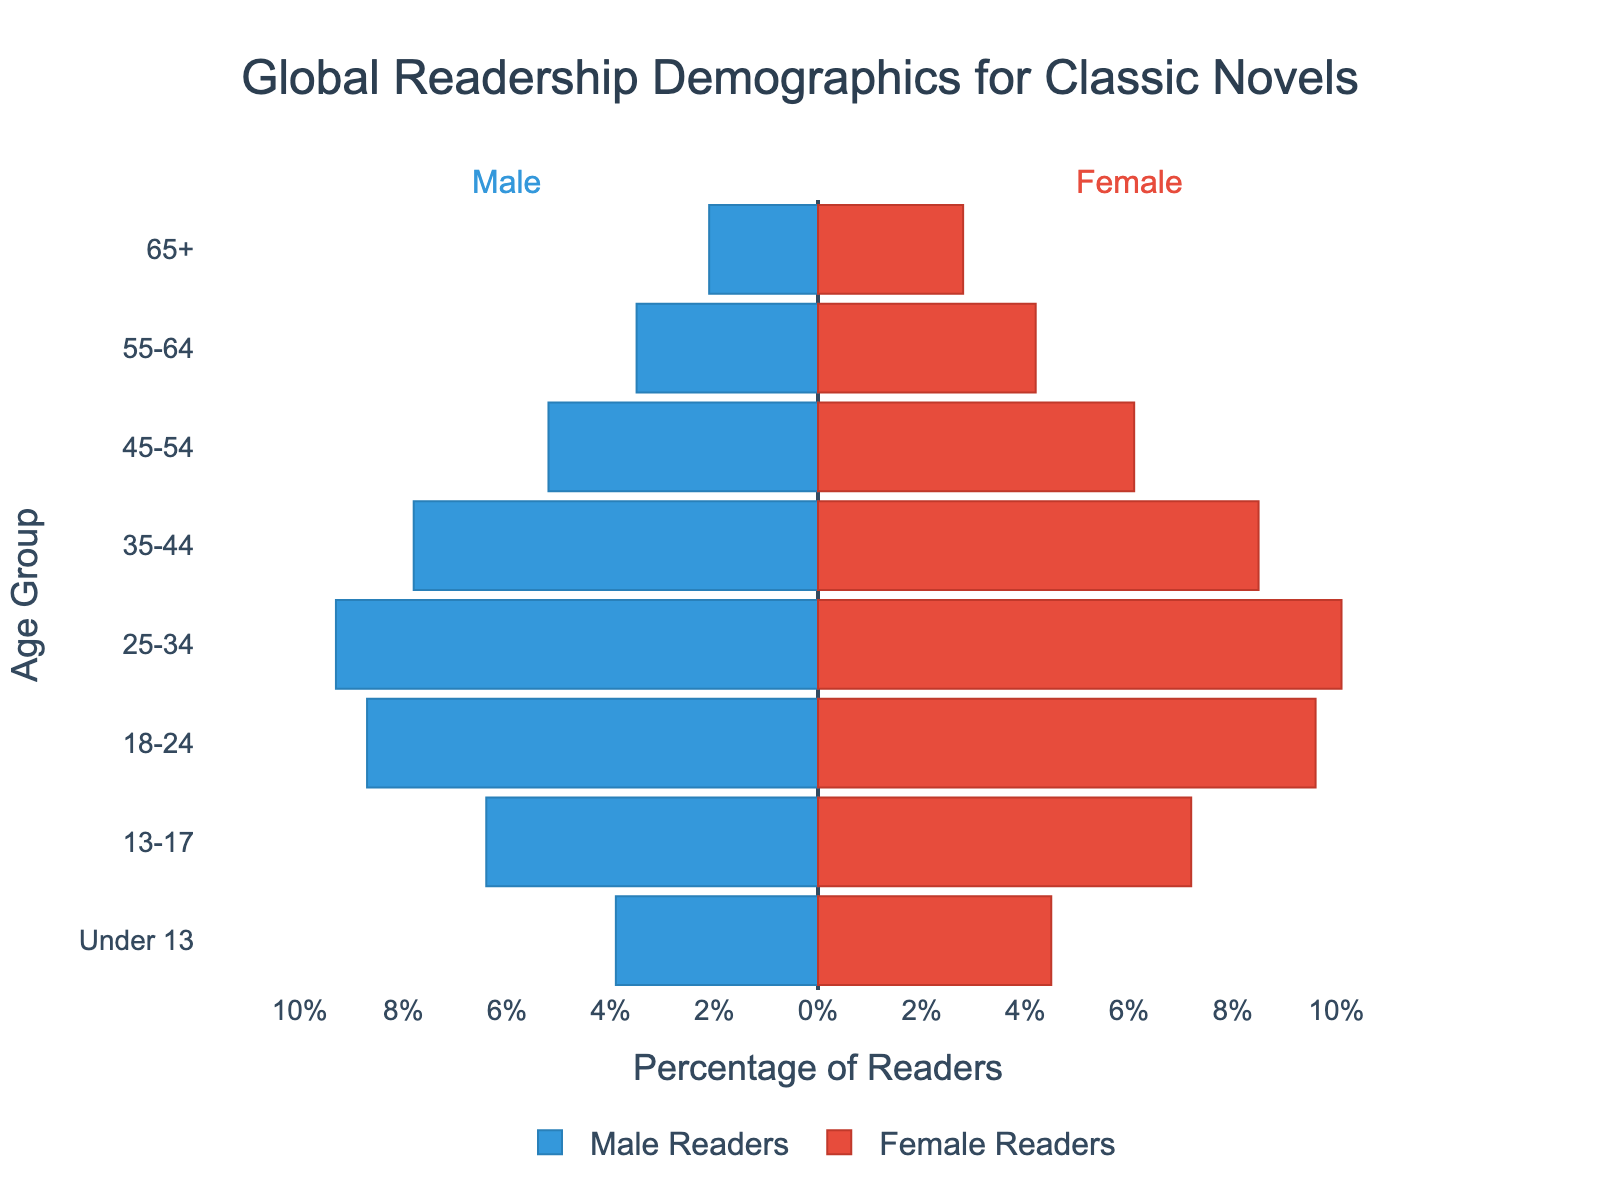what is the title of the figure? The title is prominently displayed at the top center of the figure in a large, bold font.
Answer: Global Readership Demographics for Classic Novels What color represents male readers in the plot? The bars representing male readers are colored in a specific shade of blue.
Answer: Blue What's the percentage of female readers in the 25-34 age group? Look at the bar for the 25-34 age group on the female (right) side of the plot; the label shows the percentage.
Answer: 10.1% How many age groups are presented in the plot? Count the unique age groups listed on the y-axis of the plot.
Answer: 8 Which age group has the highest percentage of male readers? Compare the length of the blue bars for each age group to find the one that extends the furthest to the left.
Answer: 25-34 What's the difference between the percentage of female readers and male readers in the 18-24 age group? Subtract the percentage of male readers from the percentage of female readers for the 18-24 age group.
Answer: 0.9 Comparing age groups 55-64 and 65+, which has a higher percentage of female readers? Compare the lengths of the red bars for the 55-64 and 65+ age groups.
Answer: 55-64 What is the sum of percentages of male readers in the 13-17 and Under 13 age groups? Add the percentages of male readers for the 13-17 and Under 13 age groups.
Answer: 10.3 What is the average percentage of male and female readers in the 35-44 age group? Add the percentages of male and female readers in the 35-44 age group and divide by 2.
Answer: 8.15 Which gender's readership shows a higher overall trend in the younger age groups (Under 13 and 13-17)? Compare the bars for male and female readers in the Under 13 and 13-17 age groups; overall trend is seen by the sum of their percentages.
Answer: Female 